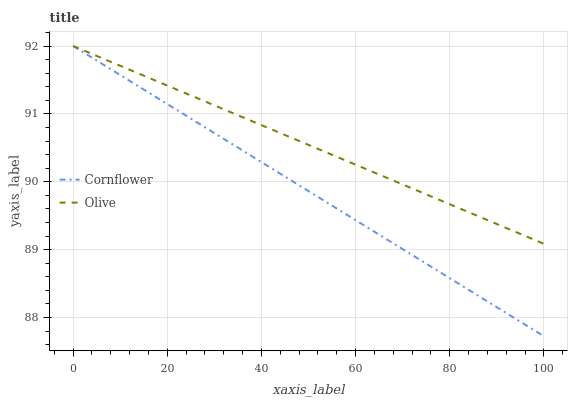Does Cornflower have the minimum area under the curve?
Answer yes or no. Yes. Does Olive have the maximum area under the curve?
Answer yes or no. Yes. Does Cornflower have the maximum area under the curve?
Answer yes or no. No. Is Olive the smoothest?
Answer yes or no. Yes. Is Cornflower the roughest?
Answer yes or no. Yes. Is Cornflower the smoothest?
Answer yes or no. No. Does Cornflower have the lowest value?
Answer yes or no. Yes. Does Cornflower have the highest value?
Answer yes or no. Yes. Does Cornflower intersect Olive?
Answer yes or no. Yes. Is Cornflower less than Olive?
Answer yes or no. No. Is Cornflower greater than Olive?
Answer yes or no. No. 